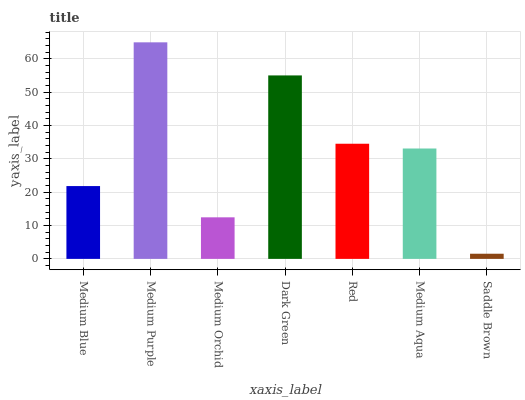Is Saddle Brown the minimum?
Answer yes or no. Yes. Is Medium Purple the maximum?
Answer yes or no. Yes. Is Medium Orchid the minimum?
Answer yes or no. No. Is Medium Orchid the maximum?
Answer yes or no. No. Is Medium Purple greater than Medium Orchid?
Answer yes or no. Yes. Is Medium Orchid less than Medium Purple?
Answer yes or no. Yes. Is Medium Orchid greater than Medium Purple?
Answer yes or no. No. Is Medium Purple less than Medium Orchid?
Answer yes or no. No. Is Medium Aqua the high median?
Answer yes or no. Yes. Is Medium Aqua the low median?
Answer yes or no. Yes. Is Dark Green the high median?
Answer yes or no. No. Is Medium Orchid the low median?
Answer yes or no. No. 